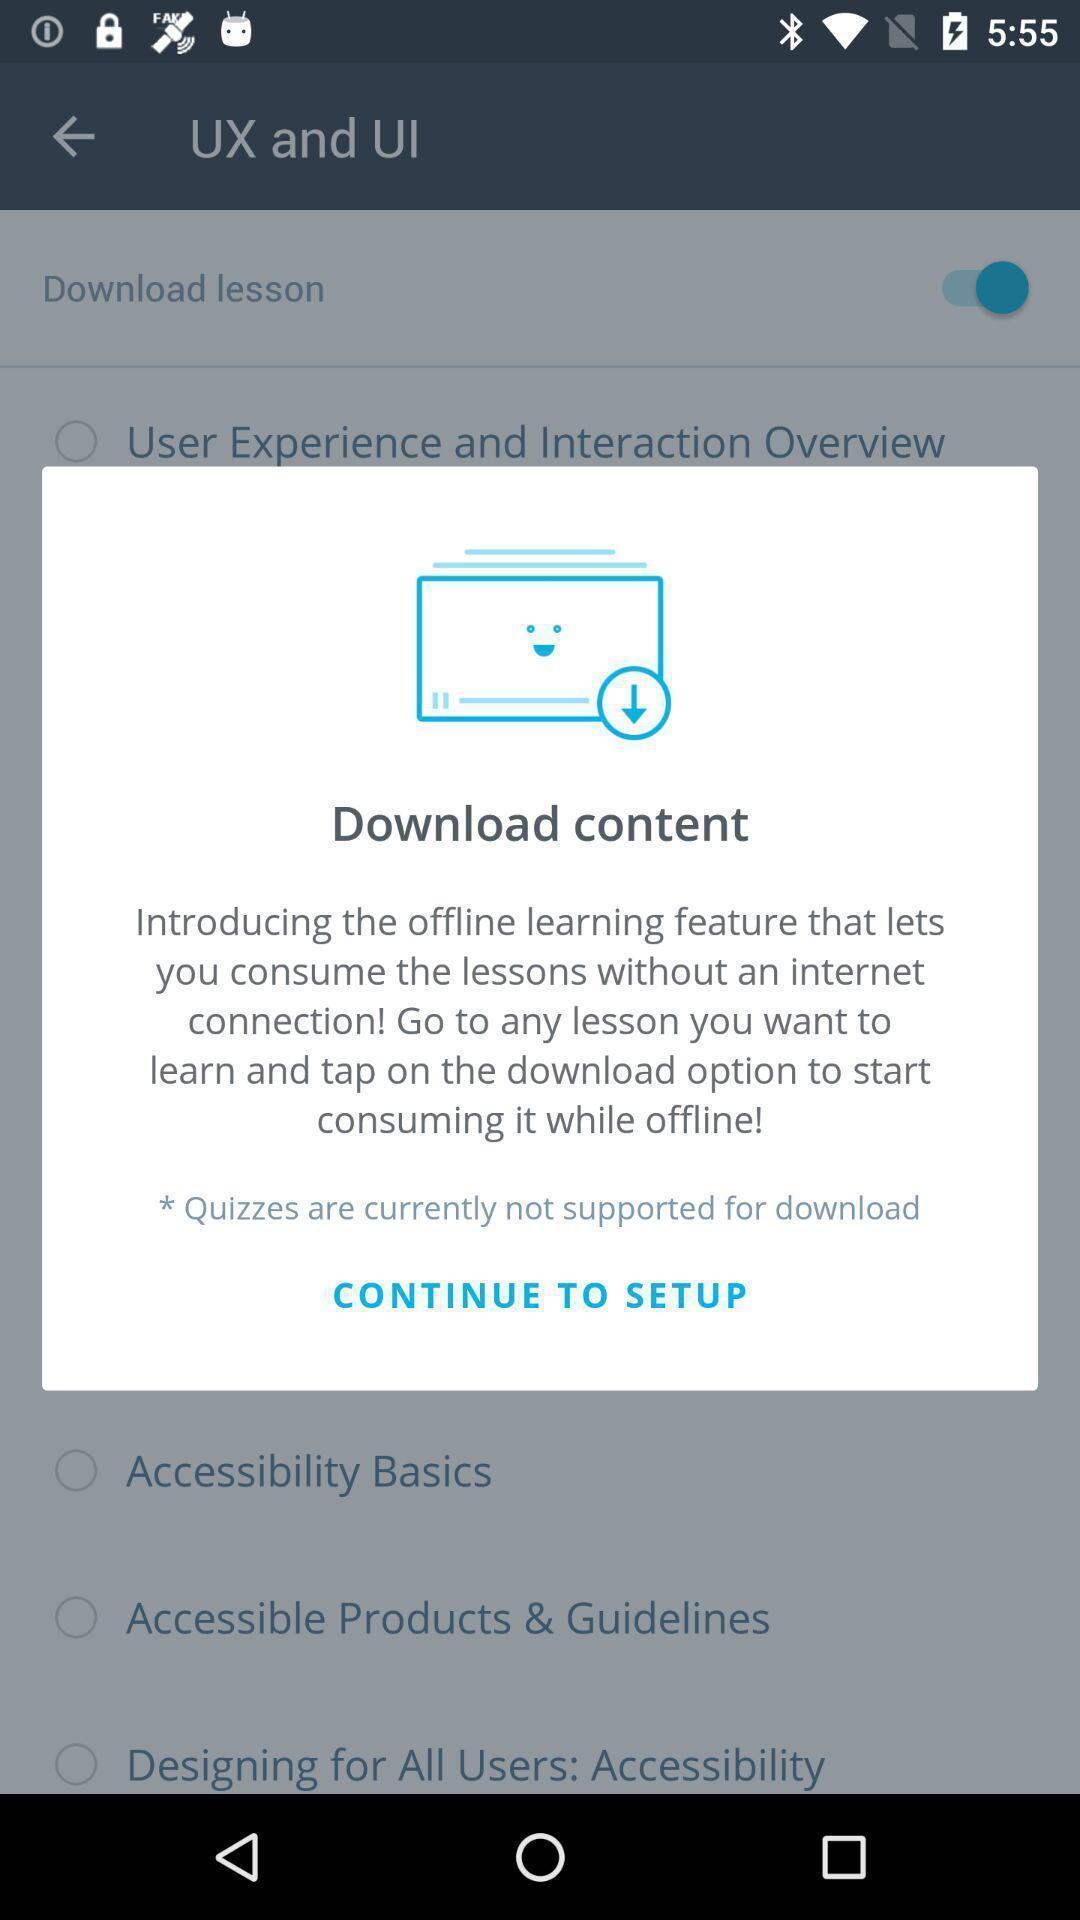What details can you identify in this image? Pop-up shows download content in learning app. 